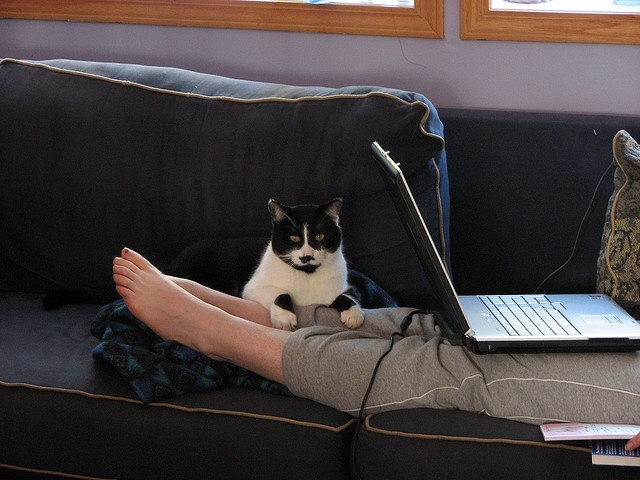Describe the objects in this image and their specific colors. I can see couch in black, maroon, gray, and darkgray tones, people in maroon, gray, and black tones, laptop in maroon, black, white, and lightblue tones, cat in maroon, black, darkgray, and tan tones, and book in maroon, lavender, darkgray, and black tones in this image. 